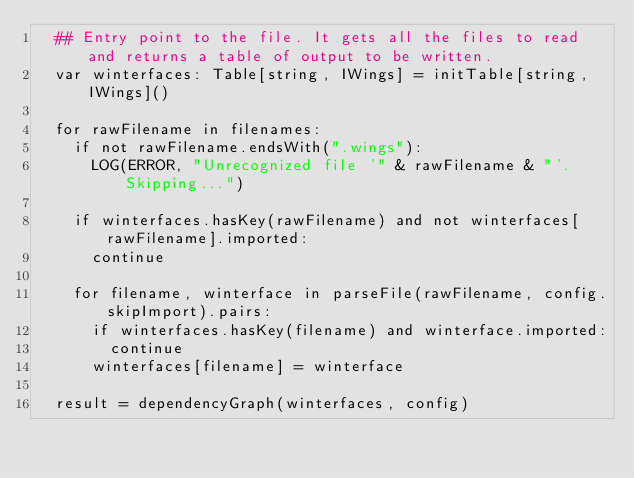Convert code to text. <code><loc_0><loc_0><loc_500><loc_500><_Nim_>  ## Entry point to the file. It gets all the files to read and returns a table of output to be written.
  var winterfaces: Table[string, IWings] = initTable[string, IWings]()

  for rawFilename in filenames:
    if not rawFilename.endsWith(".wings"):
      LOG(ERROR, "Unrecognized file '" & rawFilename & "'. Skipping...")

    if winterfaces.hasKey(rawFilename) and not winterfaces[rawFilename].imported:
      continue

    for filename, winterface in parseFile(rawFilename, config.skipImport).pairs:
      if winterfaces.hasKey(filename) and winterface.imported:
        continue
      winterfaces[filename] = winterface

  result = dependencyGraph(winterfaces, config)
</code> 